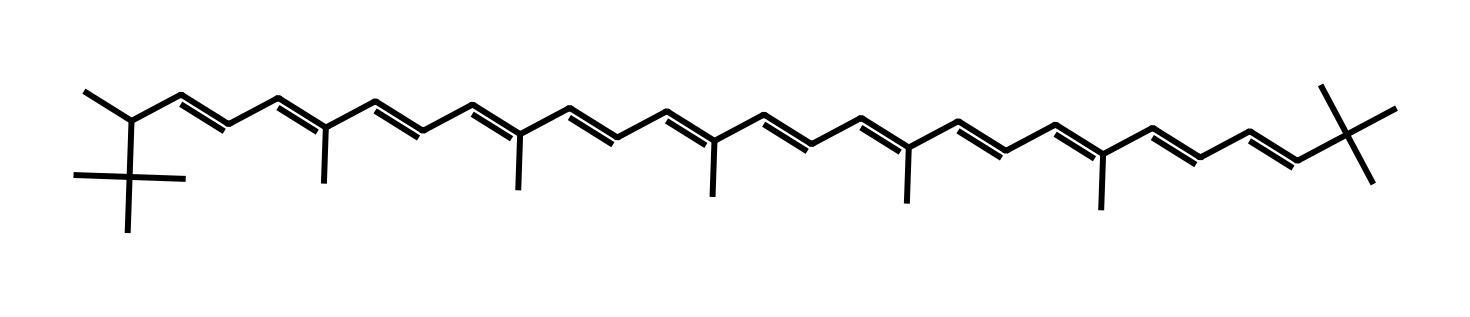What is the molecular formula of lycopene? To derive the molecular formula, one must observe the SMILES notation and count the number of each type of atom. The visual breakdown shows 40 carbons and 56 hydrogens, leading to the formula C40H56.
Answer: C40H56 How many double bonds are present in lycopene? By examining the structure based on the SMILES representation, we can identify that there are 11 double bonds between the carbon atoms in lycopene. This is typical for its conjugated system.
Answer: 11 What type of isomerism is shown by the geometric isomers of lycopene? This compound can exhibit cis-trans isomerism due to the presence of double bonds, allowing variations in spatial arrangements around these bonds.
Answer: cis-trans How many rings or cycles are in the structure of lycopene? The provided structure of lycopene, as seen in the SMILES notation, contains no cyclic structures; all carbon atoms are part of a linear or branched chain setup.
Answer: 0 Which functional group is primarily responsible for lycopene's properties? Lycopene mainly contains alkene functional groups due to the presence of multiple double bonds, which contribute to its biochemical properties and reactivity.
Answer: alkene How many total carbon atoms are branching in the lycopene structure? From the SMILES representation, the structure indicates branching at specific carbon atoms. Upon analysis, there are 5 carbon atoms involved in branching configurations within the long chain.
Answer: 5 